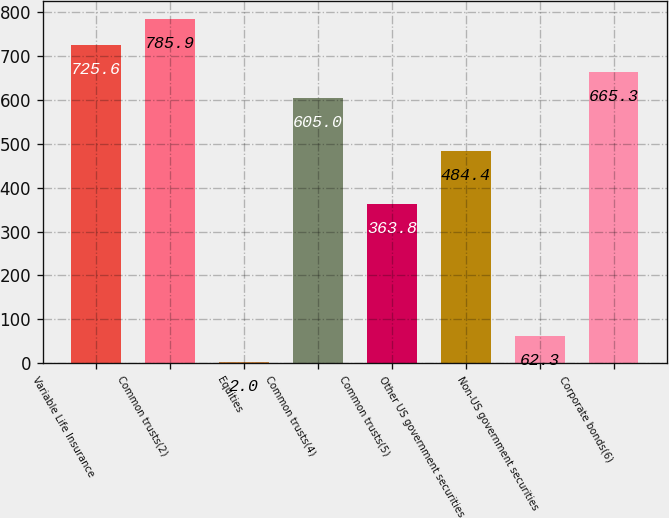<chart> <loc_0><loc_0><loc_500><loc_500><bar_chart><fcel>Variable Life Insurance<fcel>Common trusts(2)<fcel>Equities<fcel>Common trusts(4)<fcel>Common trusts(5)<fcel>Other US government securities<fcel>Non-US government securities<fcel>Corporate bonds(6)<nl><fcel>725.6<fcel>785.9<fcel>2<fcel>605<fcel>363.8<fcel>484.4<fcel>62.3<fcel>665.3<nl></chart> 